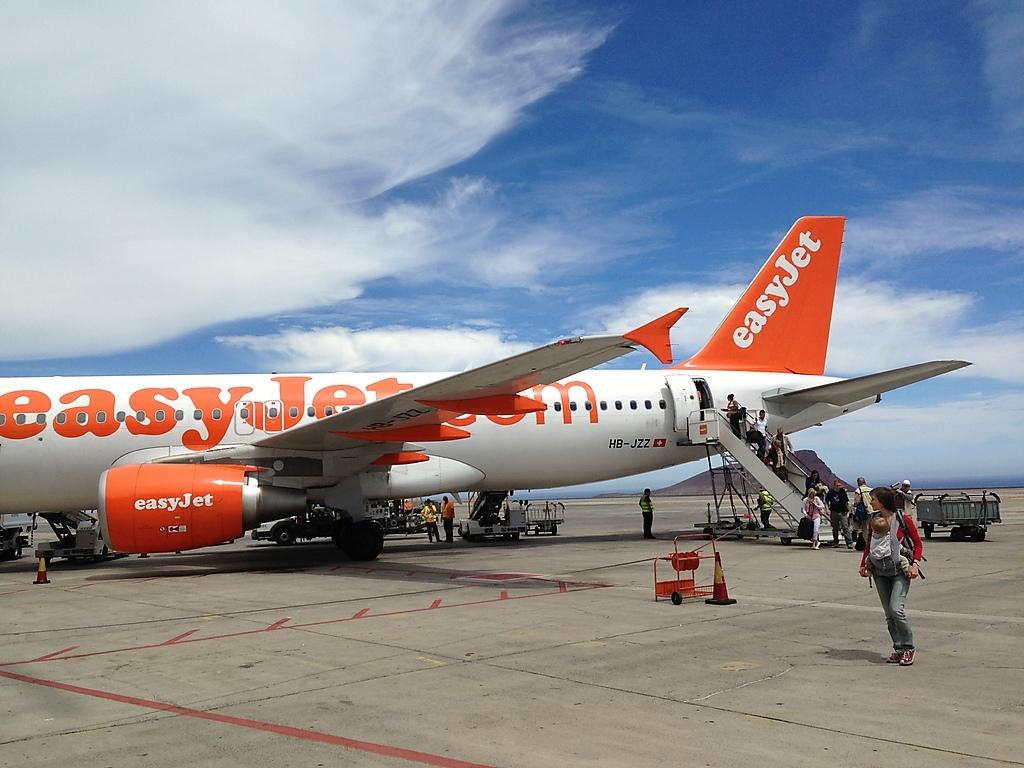<image>
Render a clear and concise summary of the photo. A woman with a baby walks away from an easyJet on a tarmac. 